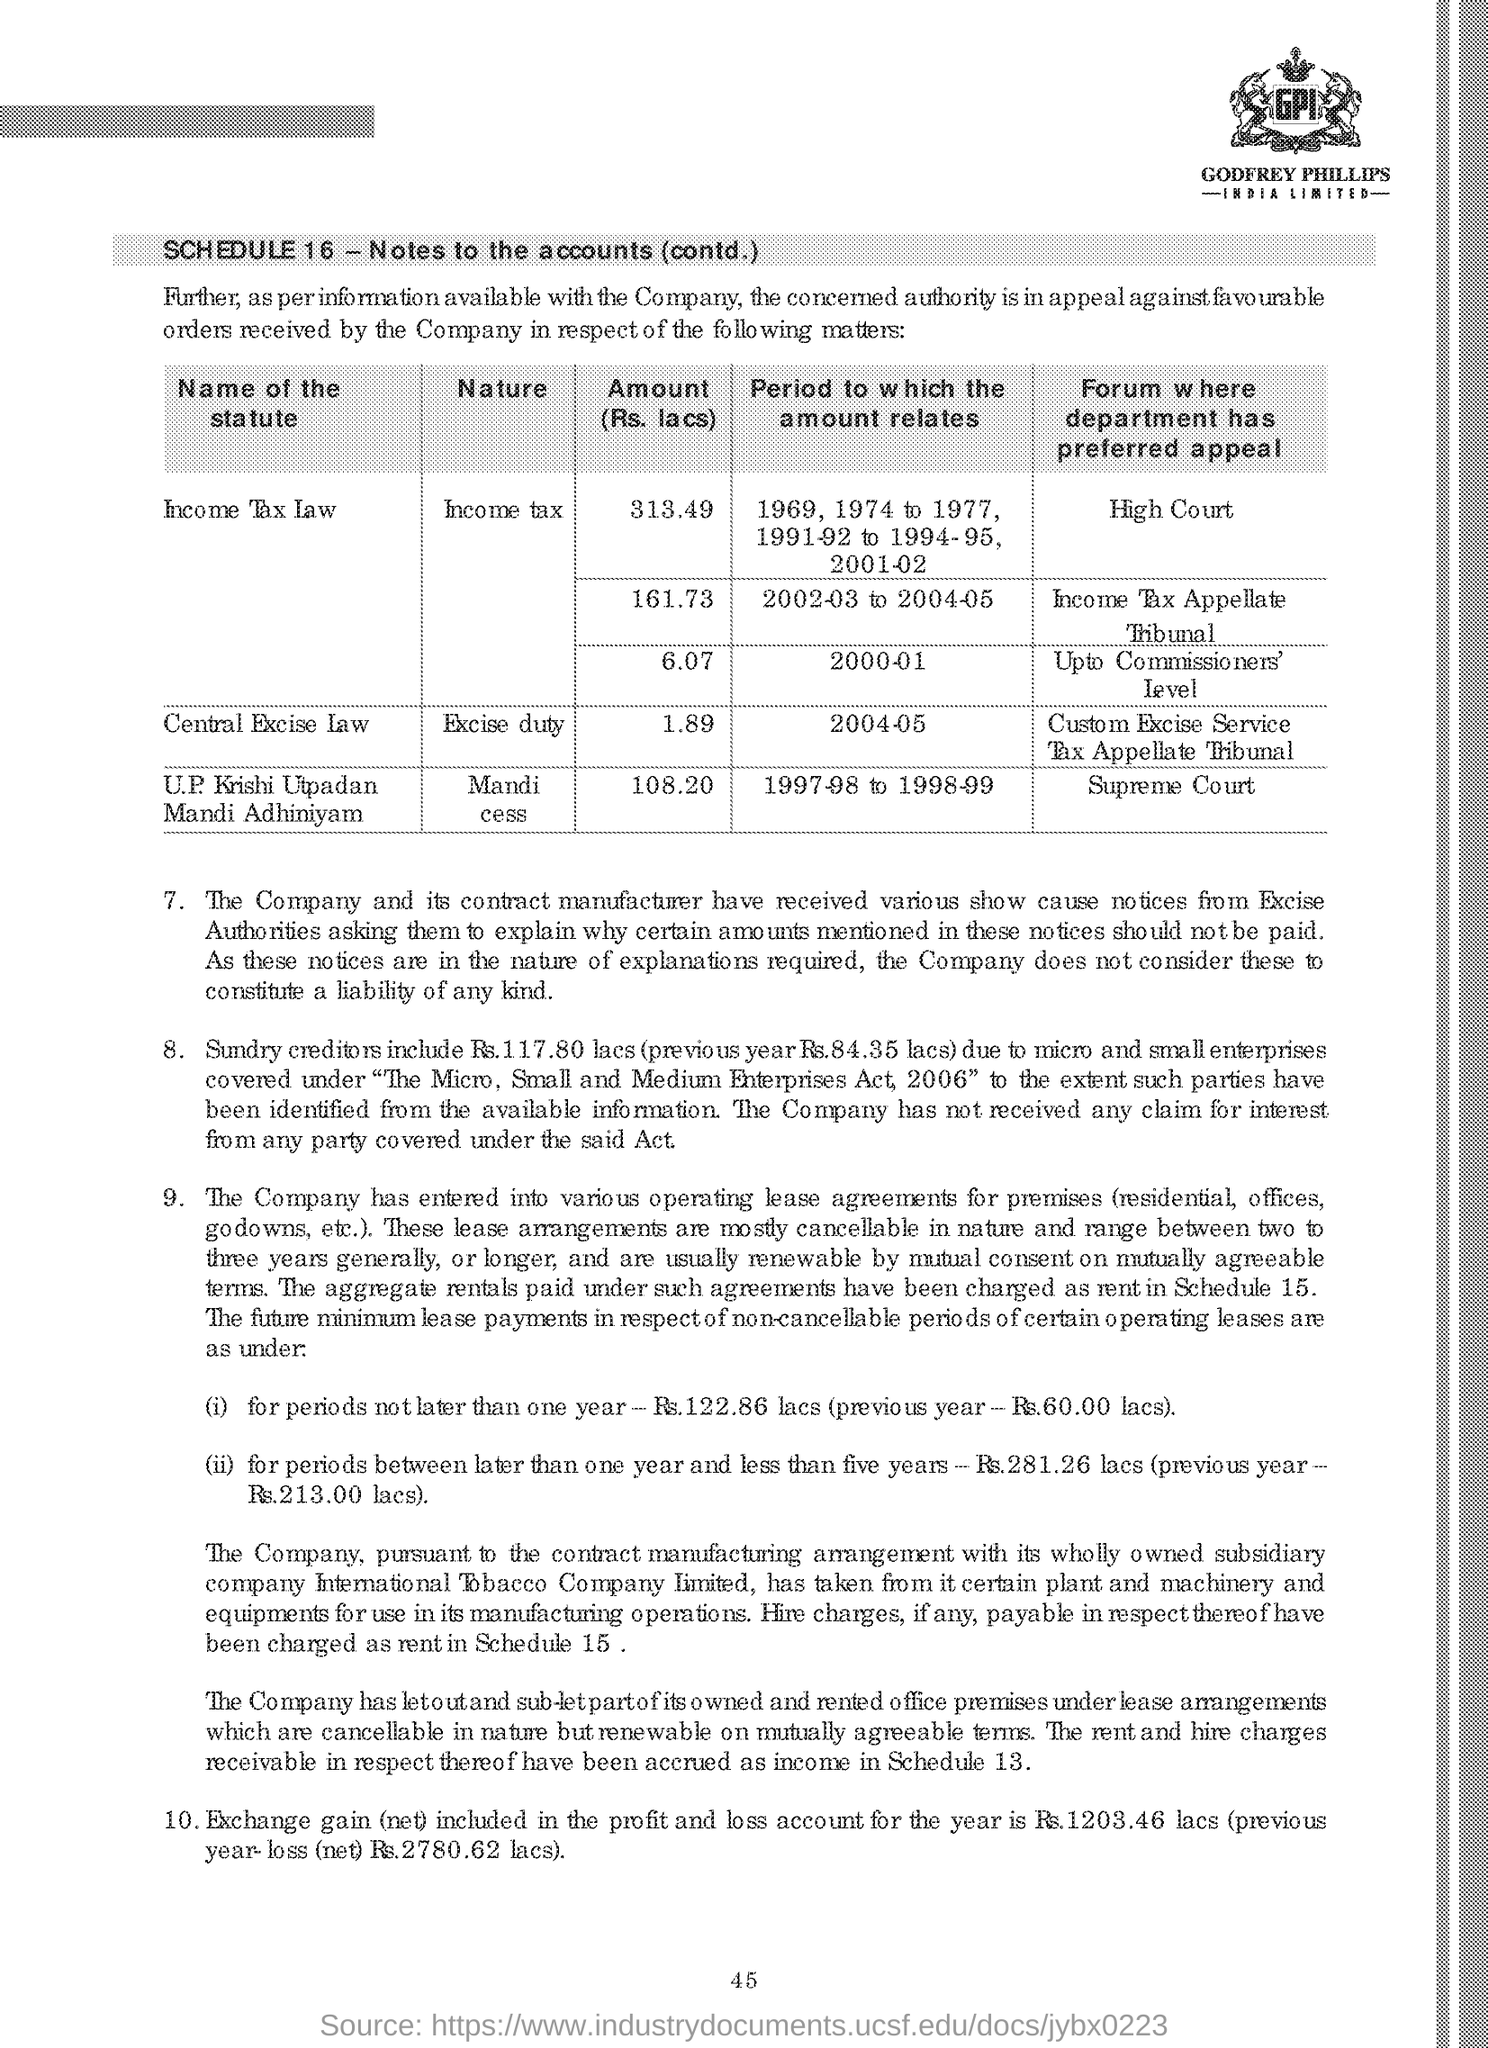What is written in the logo placed at the top right of the document?
Keep it short and to the point. GPI. What is the SCHEDULE Number given at the starting of the document?
Your response must be concise. 16. What is the 'Nature' of the statute 'U.P. Krishi Utpadan Mandi Adhiniyam' based on the table?
Your answer should be compact. Mandi cess. What is the 'Period to which the amount relates' for 'Central Excise law' ?
Offer a terse response. 2004-05. How much is the amount in lacs for the period 2000-01 for statute 'Income Tax law' ?
Your answer should be very brief. 6.07. What is the first statute in the table ?
Your response must be concise. Income Tax Law. 